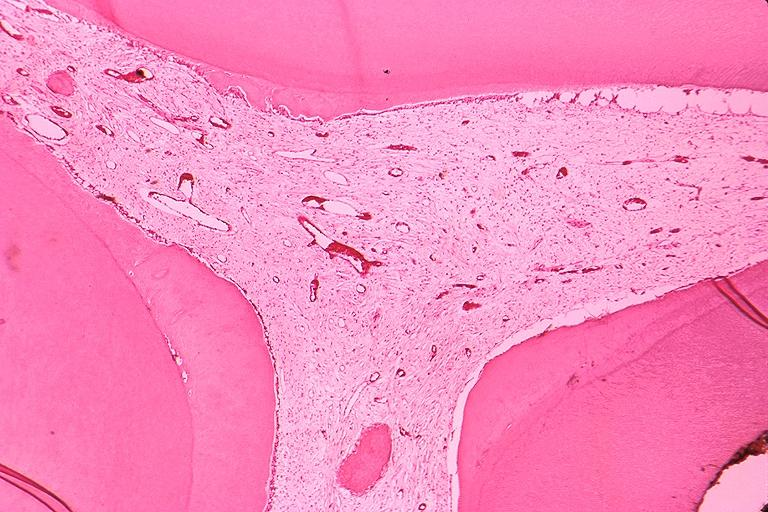what is present?
Answer the question using a single word or phrase. Oral 